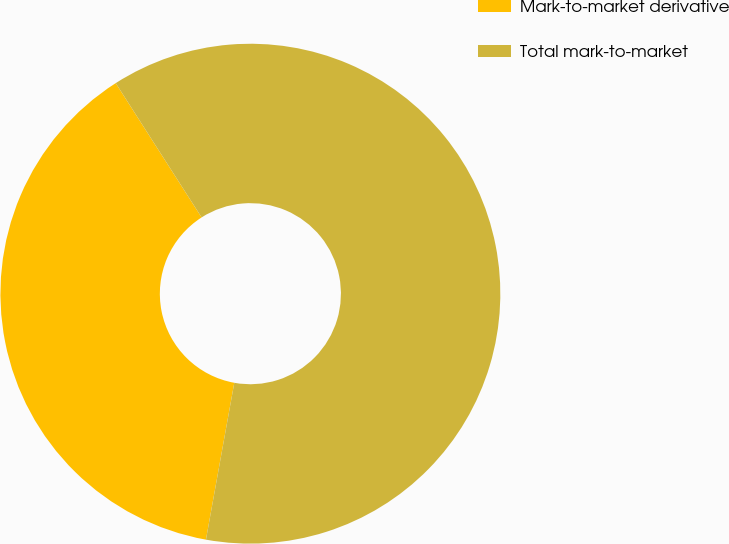<chart> <loc_0><loc_0><loc_500><loc_500><pie_chart><fcel>Mark-to-market derivative<fcel>Total mark-to-market<nl><fcel>38.1%<fcel>61.9%<nl></chart> 